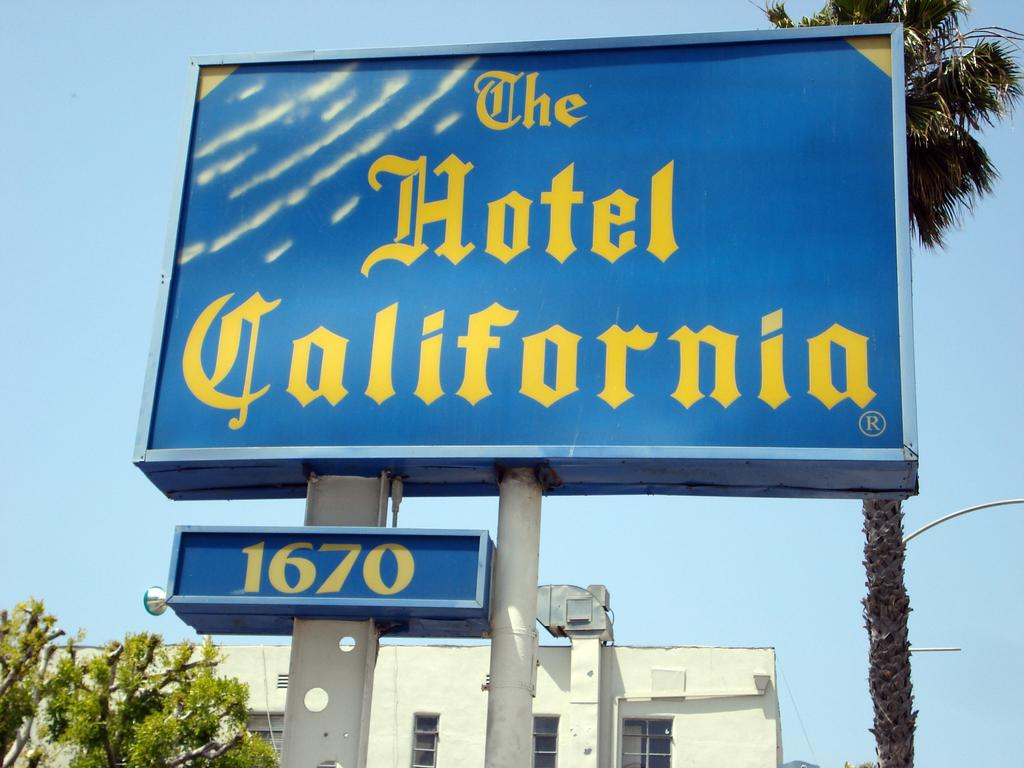<image>
Describe the image concisely. a blue and yellow sign for The Hotel California 1670 